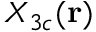Convert formula to latex. <formula><loc_0><loc_0><loc_500><loc_500>X _ { 3 c } ( r )</formula> 